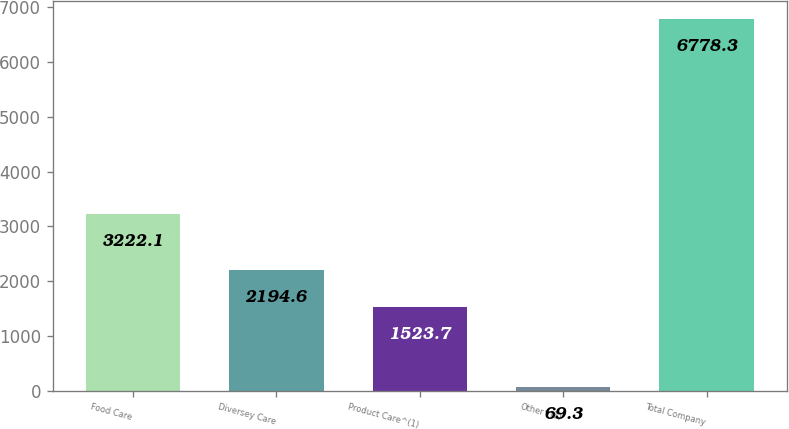Convert chart to OTSL. <chart><loc_0><loc_0><loc_500><loc_500><bar_chart><fcel>Food Care<fcel>Diversey Care<fcel>Product Care^(1)<fcel>Other^(1)<fcel>Total Company<nl><fcel>3222.1<fcel>2194.6<fcel>1523.7<fcel>69.3<fcel>6778.3<nl></chart> 